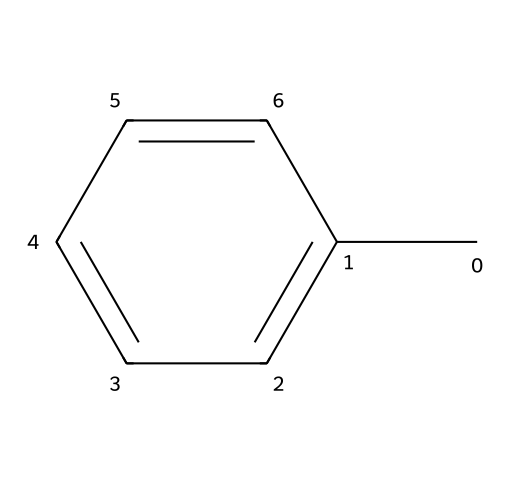What is the molecular formula of toluene? To determine the molecular formula, count the number of carbon (C) and hydrogen (H) atoms in the structure. There are 7 carbon atoms and 8 hydrogen atoms. Therefore, the molecular formula is C7H8.
Answer: C7H8 How many carbon atoms are in toluene? The structure shows a total of 7 carbon atoms based on the visual representation of the chemical.
Answer: 7 What is the main functional group in toluene? Toluene contains a methyl group attached to a benzene ring, so the primary functional group can be identified as an aryl group.
Answer: aryl Is toluene a saturated or unsaturated compound? The presence of a benzene ring indicates that toluene is unsaturated due to the alternating double bonds within the ring structure.
Answer: unsaturated What is the bond type between carbon atoms in the benzene ring of toluene? In the benzene ring, carbon atoms are connected by alternating single and double bonds, which are characteristic of aromatic compounds.
Answer: alternating Which theory explains the stability of toluene's structure? The stability of toluene's structure is explained by aromaticity, which arises from the delocalization of pi electrons within the cyclic structure.
Answer: aromaticity How does toluene's structure contribute to its use in adhesives? The presence of the aromatic ring contributes to the strength and stability of toluene, making it an effective solvent and adhesive component, due to its ability to dissolve various substances.
Answer: stability 